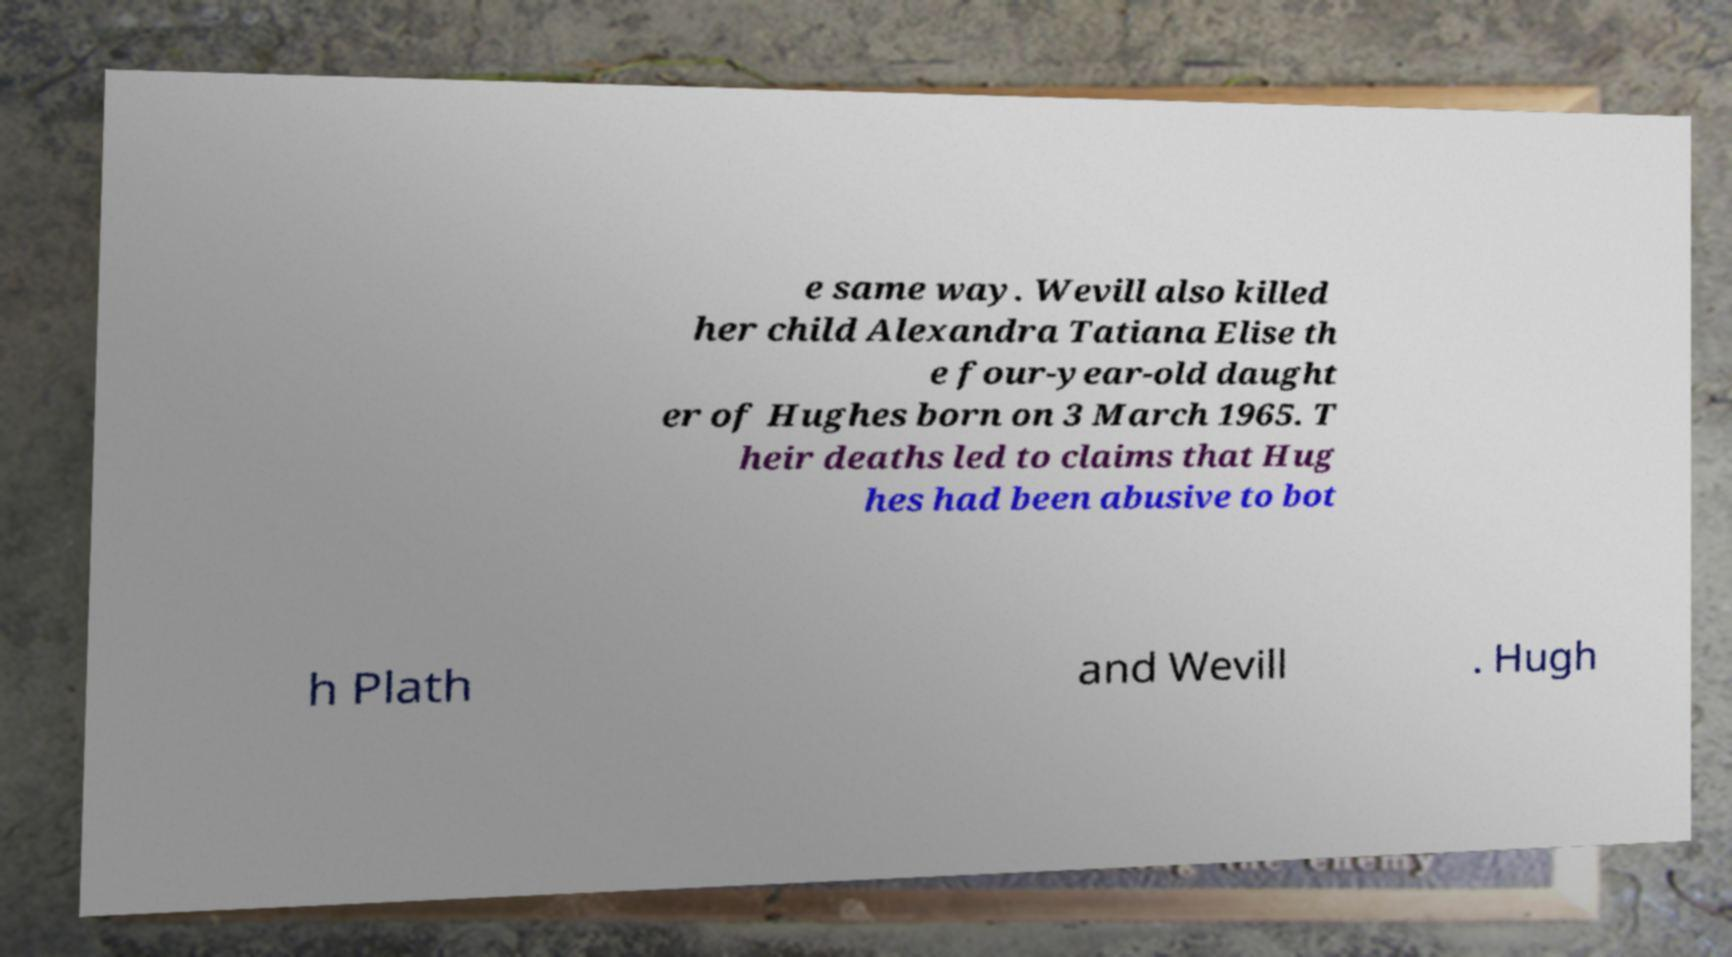Can you accurately transcribe the text from the provided image for me? e same way. Wevill also killed her child Alexandra Tatiana Elise th e four-year-old daught er of Hughes born on 3 March 1965. T heir deaths led to claims that Hug hes had been abusive to bot h Plath and Wevill . Hugh 